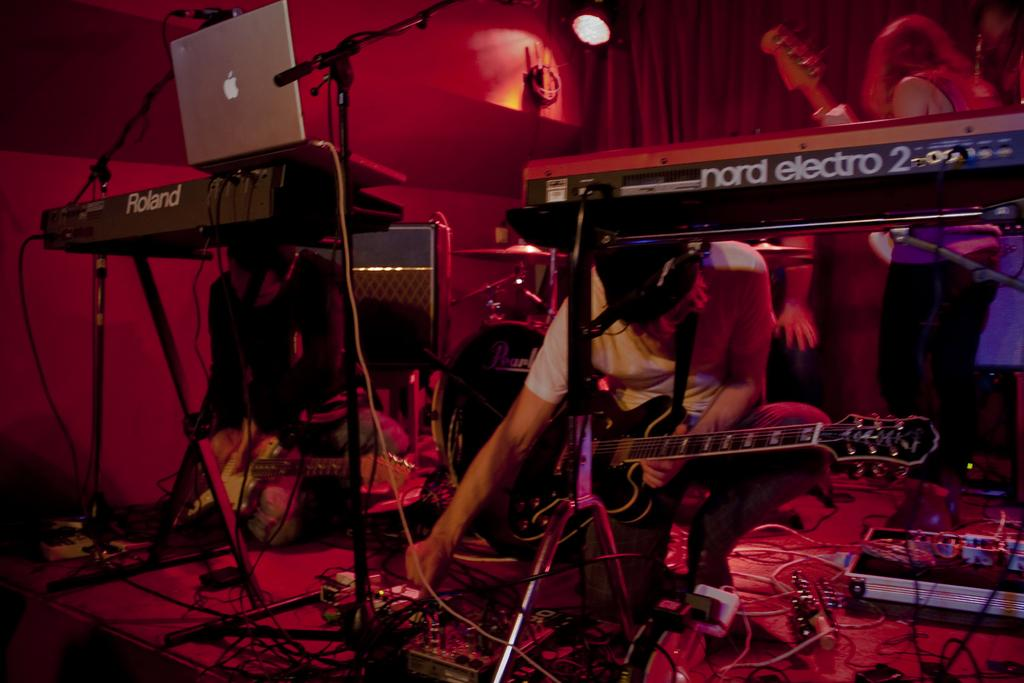What are the people in the image doing? The people in the image are holding musical instruments. What electronic device is visible in the image? A laptop is visible in the image. What type of objects are present in the image that are used for creating music? Musical instruments are present in the image. What type of objects are present in the image that are used for connecting devices? Wires are visible in the image. What type of objects are present in the image that provide illumination? Lights are present in the image. What type of objects are present on the floor in the image? There are other objects on the floor in the image. What type of crime is being committed in the image? There is no crime being committed in the image. What type of base is supporting the musical instruments in the image? There is no base supporting the musical instruments in the image; they are being held by the people. 